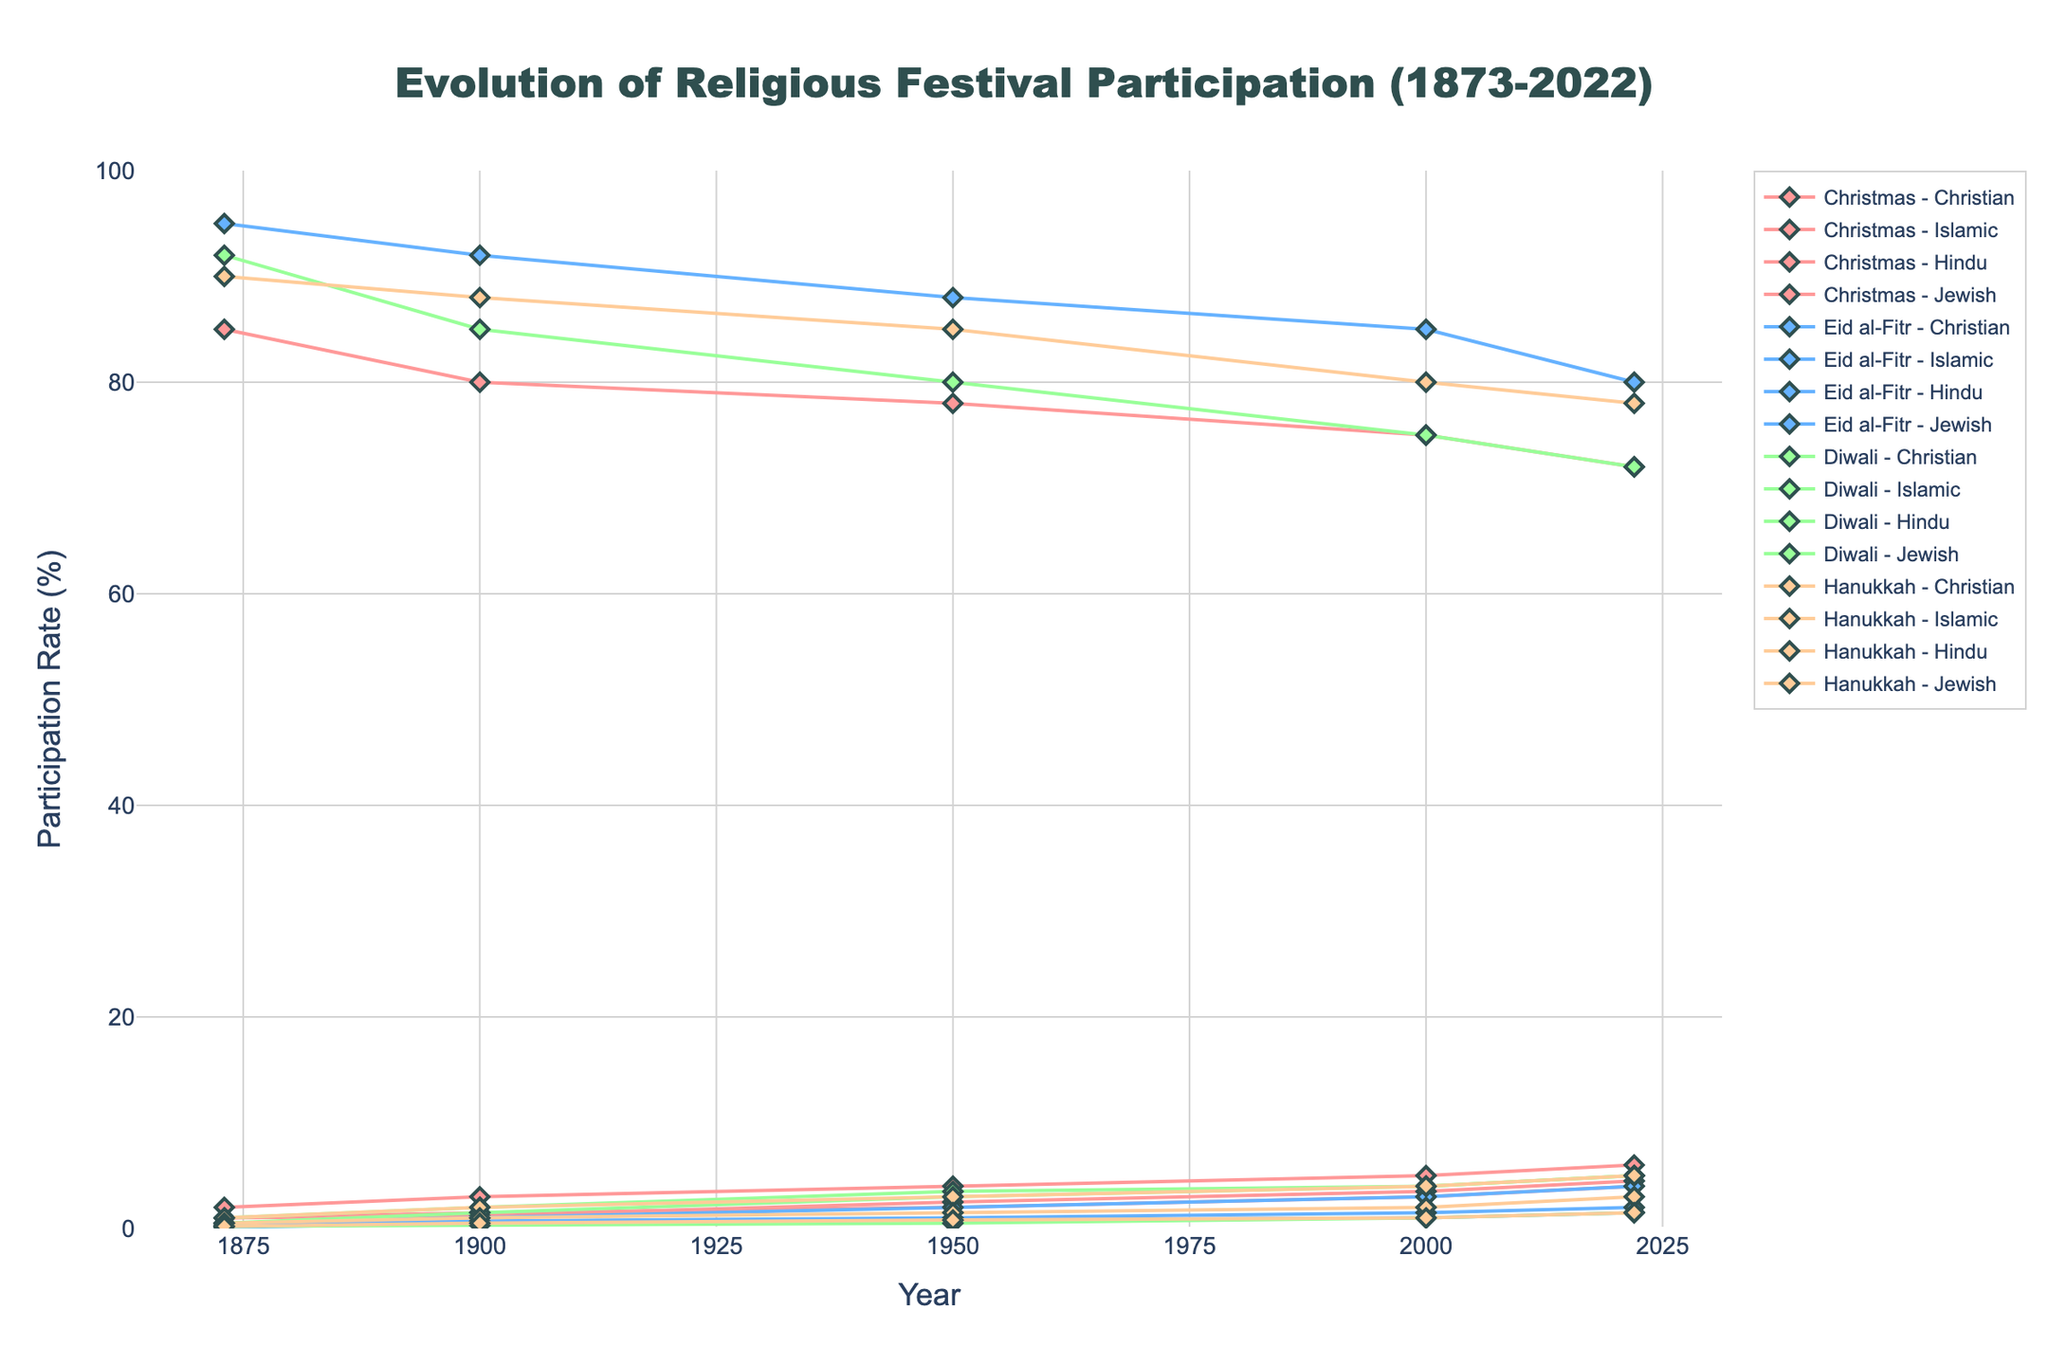What is the title of the figure? The title of the figure is displayed at the top and reads "Evolution of Religious Festival Participation (1873-2022)"
Answer: Evolution of Religious Festival Participation (1873-2022) Which holiday had the highest participation rate among Jewish participants in 2022? We look at the distinct lines for Jewish participation in 2022. The Hanukkah line reaches the highest participation rate for Jewish participants.
Answer: Hanukkah By how much did Islamic participation in Eid al-Fitr change from 1873 to 2022? Find the Islamic participation data points for Eid al-Fitr in 1873 and 2022 and calculate the difference: 80 (2022) - 95 (1873) = -15
Answer: -15 Compare Christian participation in Christmas in 1900 and 1950. Which year had a higher participation rate and by how much? Locate Christmas data points for Christian participation in 1900 and 1950, then subtract the 1950 value from the 1900 value: 80 (1900) - 78 (1950) = 2. 1900 had a higher participation rate by 2.
Answer: 1900, by 2 What is the overall trend of Hindu participation in Diwali from 1873 to 2022? Look at the Hindu participation line for Diwali across the years. It starts at 92 in 1873, goes down to 85 in 1900, continues decreasing to 80 in 1950, then to 75 in 2000, and finally 72 in 2022. The trend is decreasing.
Answer: Decreasing Which religious group's participation in Christmas has increased the most from 1873 to 2022? Compare the participation rates of Islamic, Hindu, Jewish, and other groups in Christmas between 1873 and 2022 and find the group with the largest difference. Islamic participation increased from 1 to 4, a difference of 3.
Answer: Islamic What are the participation rates for Christian participants in the four holidays in 2000? Locate the data points for Christian participants for each holiday in 2000. The rates are: Christmas (75), Eid al-Fitr (3), Diwali (4), Hanukkah (4).
Answer: Christmas: 75, Eid al-Fitr: 3, Diwali: 4, Hanukkah: 4 How does the participation rate for Muslim participants in Hanukkah in 1900 compare to 2000? Locate the Muslim participation rates for Hanukkah in both 1900 and 2000. In 1900, it was 1, and in 2000, it was 2. This shows an increase of 1.
Answer: Increased by 1 What is the average participation rate of 'other' participants in Diwali over the entire time period? List the 'other' participation rates for Diwali across all years: 6.3, 11.2, 13, 16, 16.5. Calculate the average: (6.3 + 11.2 + 13 + 16 + 16.5) / 5 = 12.6
Answer: 12.6 Which holiday shows the most stable participation rate for Hindu participants from 1873 to 2022? Compare the trends in participation rates for Hindu participants across all four holidays. Diwali has the most stable decline: 92 (1873), 85 (1900), 80 (1950), 75 (2000), 72 (2022).
Answer: Diwali 